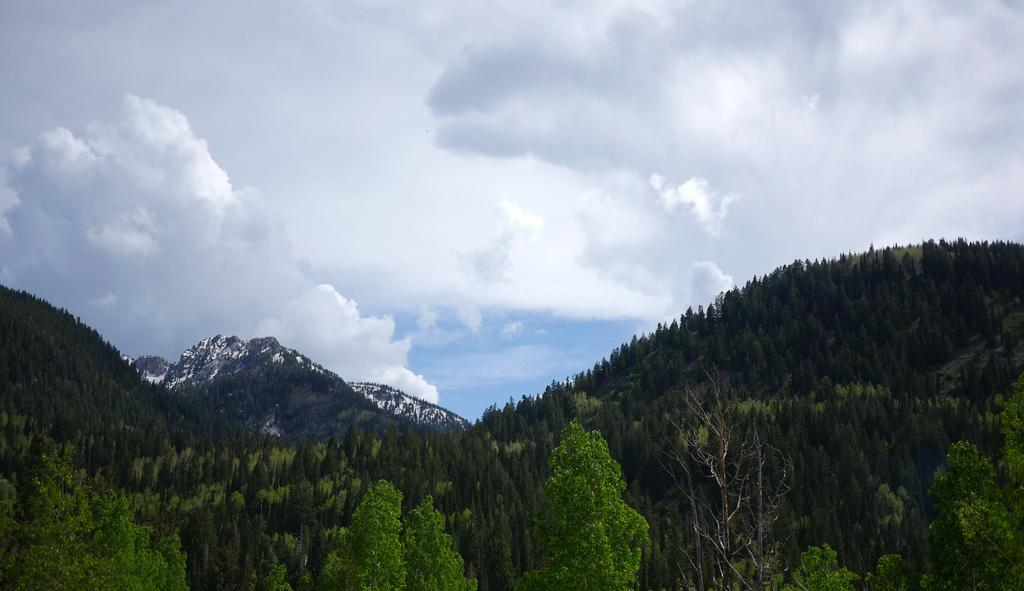What type of natural elements can be seen in the image? There are trees and hills visible in the image. What is visible in the background of the image? The sky is visible in the image. What can be observed in the sky? Clouds are present in the sky. How many feet are visible in the lunchroom in the image? There is no lunchroom present in the image, and therefore no feet can be observed. 